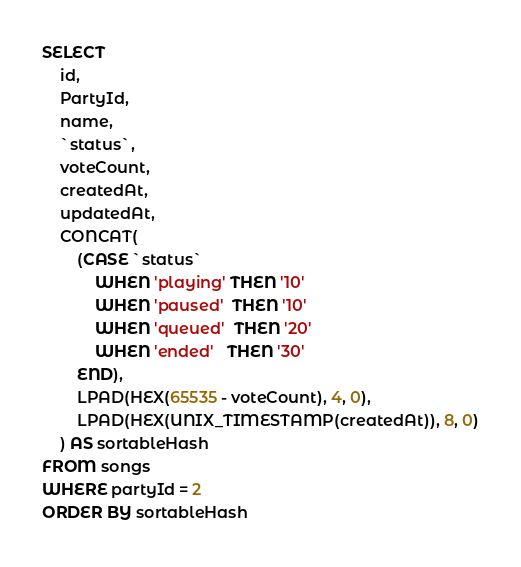Convert code to text. <code><loc_0><loc_0><loc_500><loc_500><_SQL_>SELECT
	id,
	PartyId,
	name,
	`status`,
	voteCount,
	createdAt,
	updatedAt,
	CONCAT(
		(CASE `status`
			WHEN 'playing' THEN '10'
			WHEN 'paused'  THEN '10'
			WHEN 'queued'  THEN '20'
			WHEN 'ended'   THEN '30'
		END),
		LPAD(HEX(65535 - voteCount), 4, 0),
		LPAD(HEX(UNIX_TIMESTAMP(createdAt)), 8, 0)
	) AS sortableHash
FROM songs
WHERE partyId = 2
ORDER BY sortableHash

</code> 